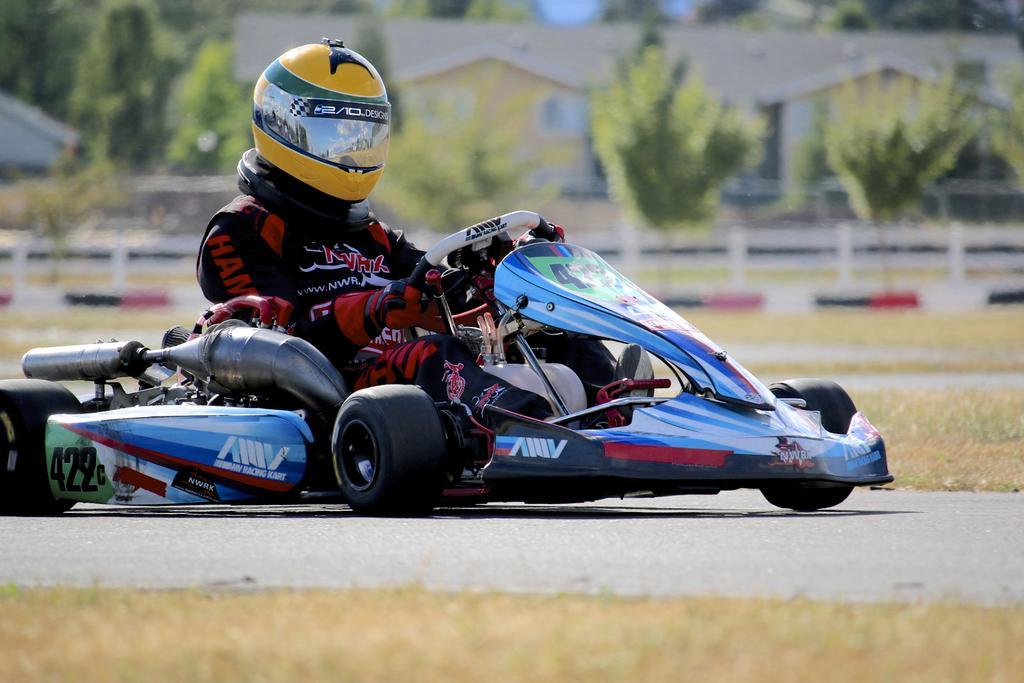Can you describe this image briefly? In this image I can see there is a person driving a racing car on the road. And at the back there is a grass, Fence, Trees and a building. 